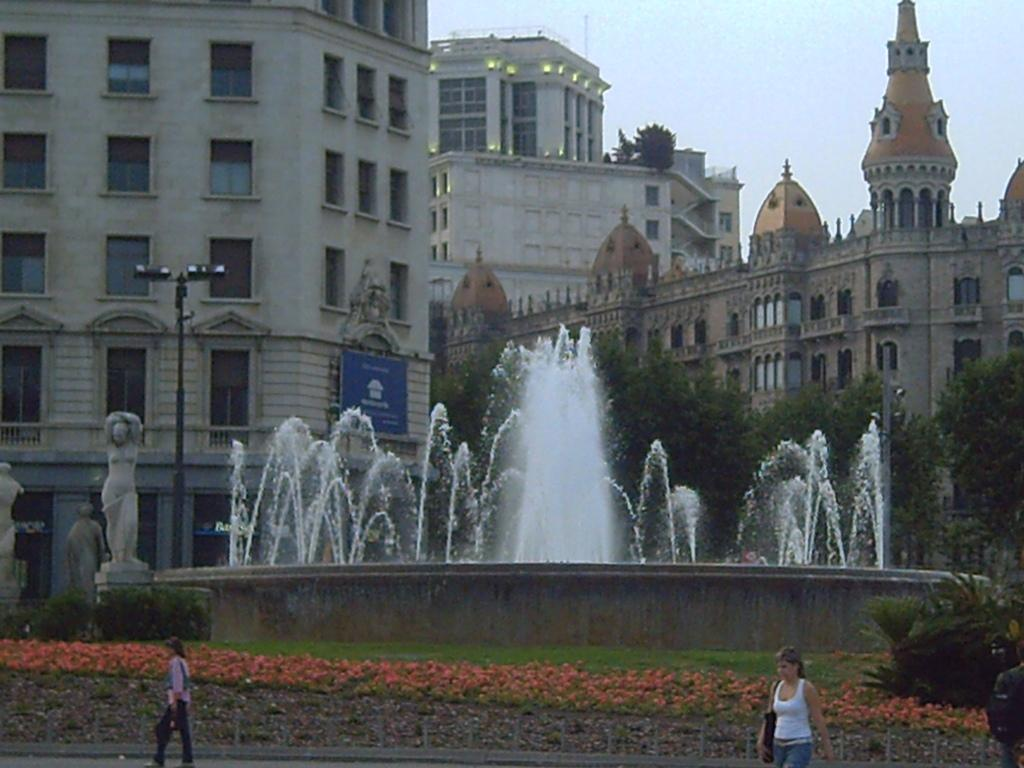How many women are in the image? There are two women in the image. What can be seen in the image besides the women? There are plants, grass, poles on the ground, buildings in the background, a water fountain in the background, and the sky and trees in the background. What type of vegetation is present in the image? There are plants and grass in the image. What architectural features can be seen in the background of the image? There are buildings in the background of the image. What natural elements are visible in the background of the image? The sky, trees, and water fountain are visible in the background of the image. What type of haircut does the boy in the image have? There is no boy present in the image, so it is not possible to answer that question. 